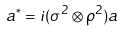<formula> <loc_0><loc_0><loc_500><loc_500>a ^ { * } = i ( \sigma ^ { 2 } \otimes \rho ^ { 2 } ) a</formula> 